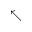Convert formula to latex. <formula><loc_0><loc_0><loc_500><loc_500>\nwarrow</formula> 